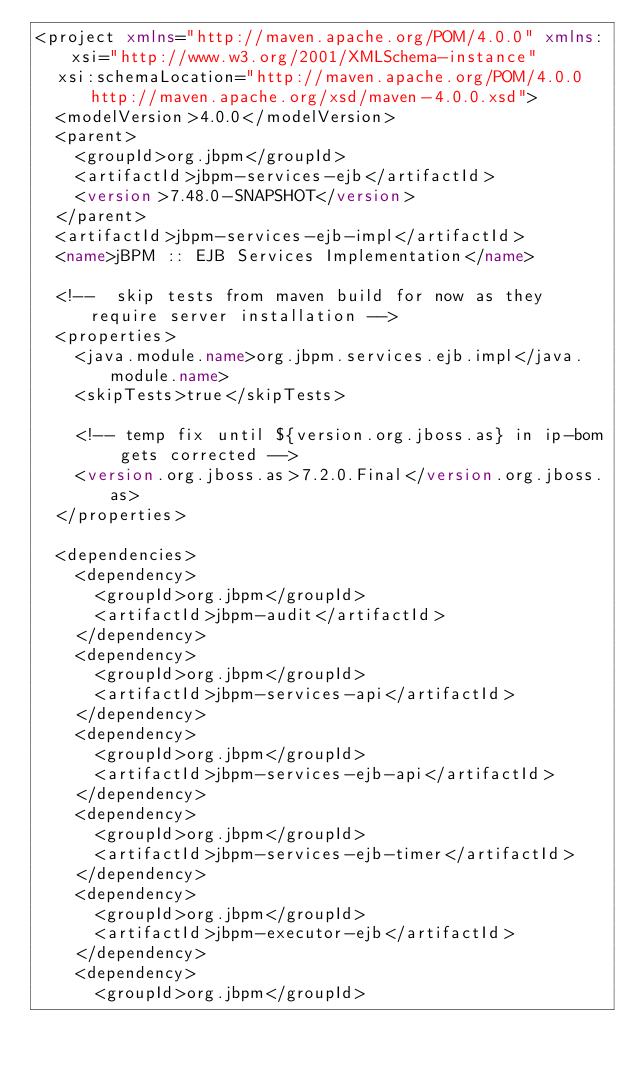<code> <loc_0><loc_0><loc_500><loc_500><_XML_><project xmlns="http://maven.apache.org/POM/4.0.0" xmlns:xsi="http://www.w3.org/2001/XMLSchema-instance"
  xsi:schemaLocation="http://maven.apache.org/POM/4.0.0 http://maven.apache.org/xsd/maven-4.0.0.xsd">
  <modelVersion>4.0.0</modelVersion>
  <parent>
    <groupId>org.jbpm</groupId>
    <artifactId>jbpm-services-ejb</artifactId>
    <version>7.48.0-SNAPSHOT</version>
  </parent>
  <artifactId>jbpm-services-ejb-impl</artifactId>
  <name>jBPM :: EJB Services Implementation</name>
  
  <!--  skip tests from maven build for now as they require server installation -->
  <properties>
    <java.module.name>org.jbpm.services.ejb.impl</java.module.name>
    <skipTests>true</skipTests>
    
    <!-- temp fix until ${version.org.jboss.as} in ip-bom gets corrected -->  
    <version.org.jboss.as>7.2.0.Final</version.org.jboss.as>
  </properties>
  
  <dependencies>
    <dependency>
      <groupId>org.jbpm</groupId>
      <artifactId>jbpm-audit</artifactId>
    </dependency>
    <dependency>
      <groupId>org.jbpm</groupId>
      <artifactId>jbpm-services-api</artifactId>
    </dependency>
    <dependency>
      <groupId>org.jbpm</groupId>
      <artifactId>jbpm-services-ejb-api</artifactId>
    </dependency>
    <dependency>
      <groupId>org.jbpm</groupId>
      <artifactId>jbpm-services-ejb-timer</artifactId>
    </dependency>
    <dependency>
      <groupId>org.jbpm</groupId>
      <artifactId>jbpm-executor-ejb</artifactId>
    </dependency>
    <dependency>
      <groupId>org.jbpm</groupId></code> 